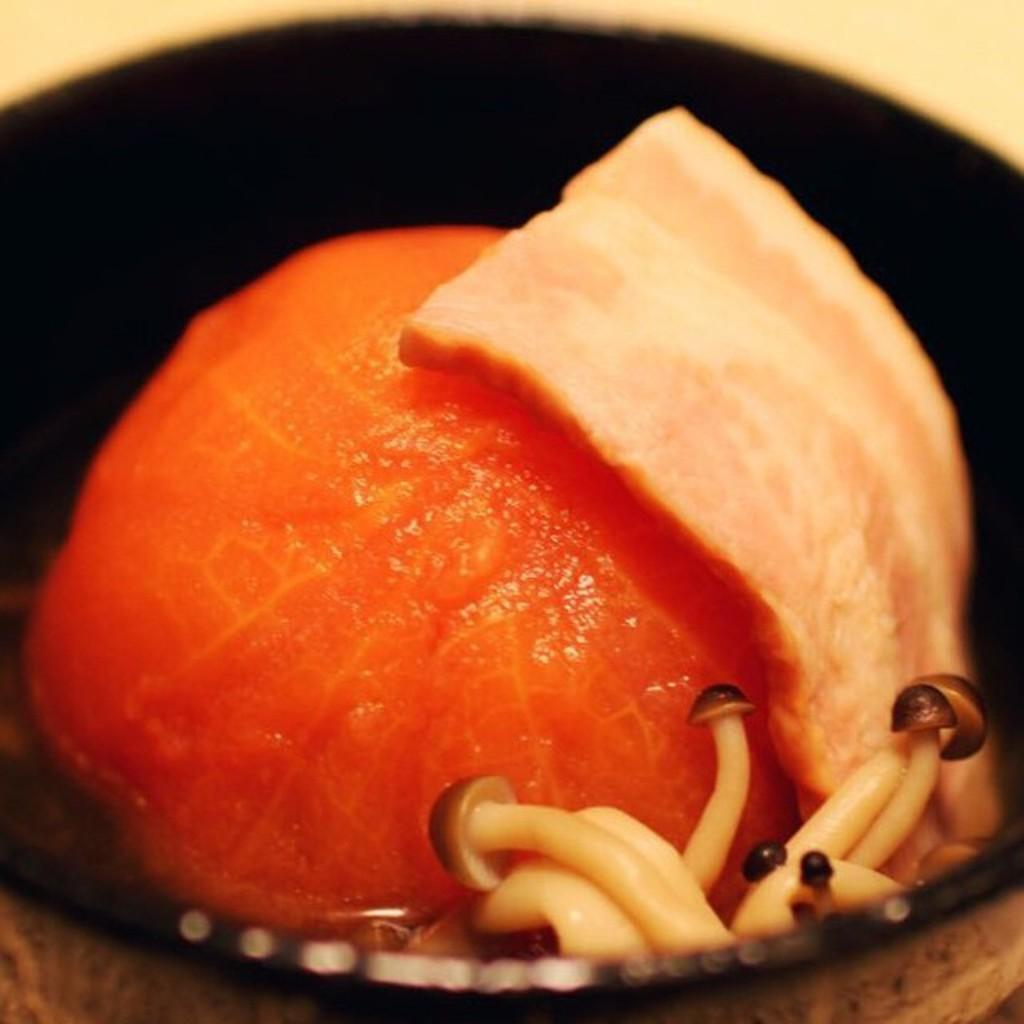What type of food can be seen in the image? There is food in the image, but the specific type is not mentioned. What specific ingredient is present in the food? There are mushrooms in the image. Where are the food and mushrooms located? The food and mushrooms are in a bowl. What color is the background of the image? The background of the image is cream-colored. What type of metal is used to control the growth of the mushrooms in the image? There is no metal or control mechanism for the mushrooms in the image; they are simply present in the food. Is there a garden visible in the image? No, there is no garden present in the image. 